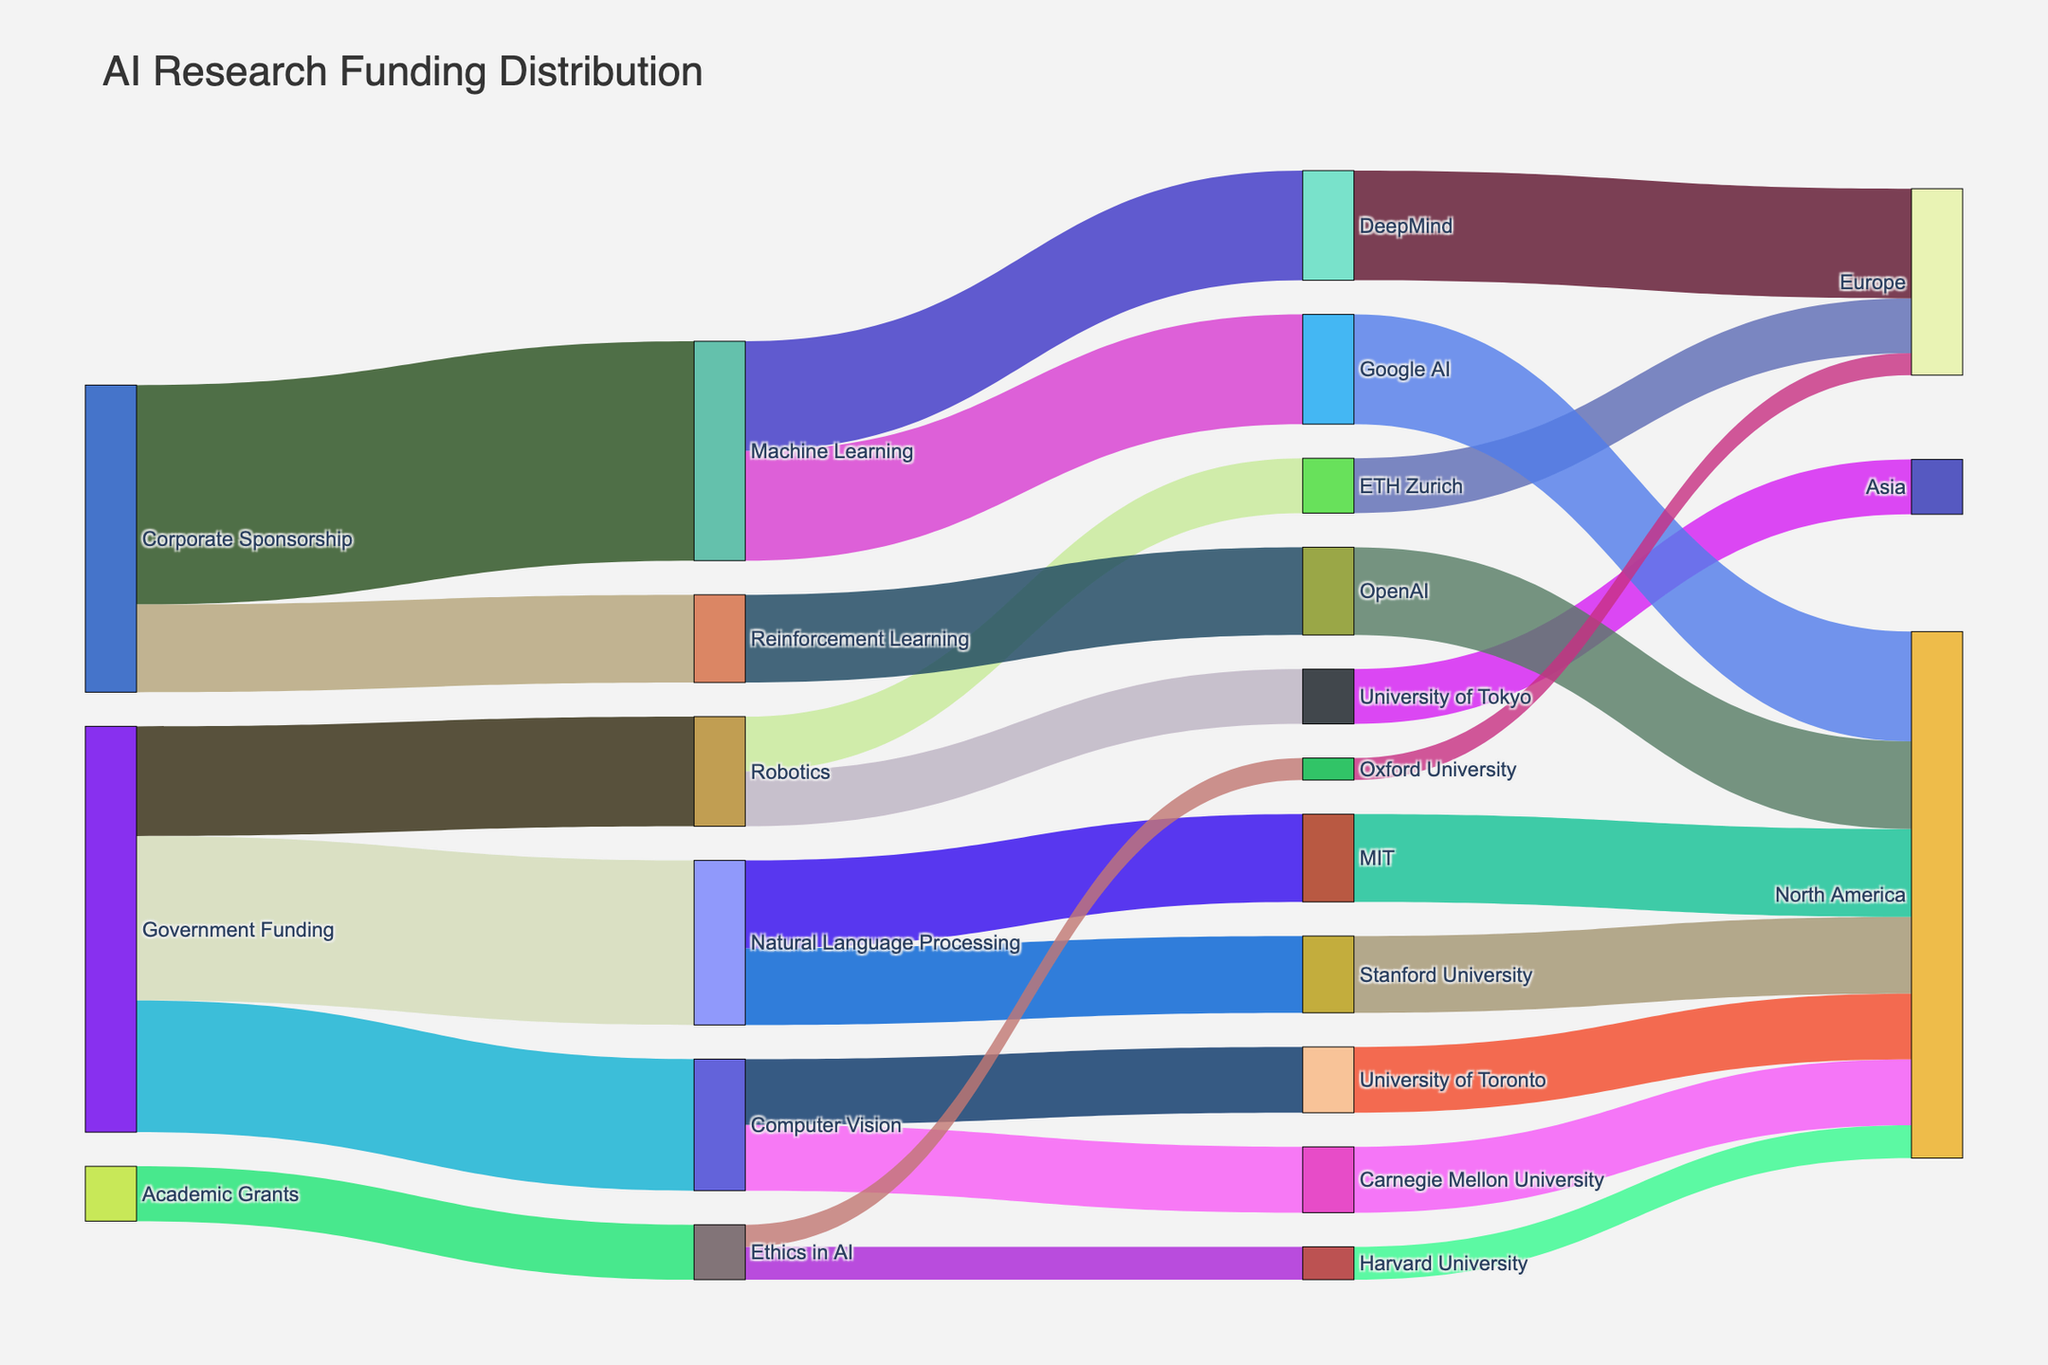What is the title of the Sankey Diagram? The title can be found at the top of the Sankey diagram, which summarizes the content being visualized.
Answer: AI Research Funding Distribution Which institution receives the maximum funding for Natural Language Processing? To find the institution that receives the most funding for Natural Language Processing, trace the largest flow leading from "Natural Language Processing" to an institution.
Answer: MIT What is the total government funding across all AI subfields? Add up the values from the "Government Funding" source that go into each AI subfield: 150 (Natural Language Processing) + 120 (Computer Vision) + 100 (Robotics).
Answer: 370 Compare the funding received by North American institutions versus European institutions. Which region receives more funding? Sum the funding for North American institutions (Stanford University, MIT, Carnegie Mellon University, University of Toronto, Google AI, OpenAI, Harvard University) and compare it with European institutions (ETH Zurich, DeepMind, Oxford University). North American institutions: 70 + 80 + 60 + 60 + 100 + 80 + 30 = 480; European institutions: 50 + 100 + 20 = 170.
Answer: North America What is the total funding received by ETH Zurich? The value can be found by tracing the flow from "Robotics" to "ETH Zurich."
Answer: 50 Identify the subfield that receives the least corporate sponsorship. Among the subfields funded by corporate sponsorship, compare the values: Machine Learning (200), Reinforcement Learning (80).
Answer: Reinforcement Learning Which geographical region gets the most overall funding? Sum the funding amounts directed to each region: North America (70 + 80 + 60 + 60 + 100 + 80 + 30) = 480; Europe (50 + 100 + 20) = 170; Asia (50).
Answer: North America How does funding for Ethics in AI compare between Harvard University and Oxford University? Compare the funding values from the "Ethics in AI" subfield to the respective universities: Harvard (30) vs. Oxford (20).
Answer: Harvard University receives more funding What is the combined funding amount for AI research at Stanford University and MIT? Add the individual funding amounts for these institutions from the "Natural Language Processing" subfield: 70 (Stanford University) + 80 (MIT).
Answer: 150 Who has provided more funding, Government Funding or Corporate Sponsorship? Sum the values for Government Funding (150 + 120 + 100 = 370) and Corporate Sponsorship (200 + 80 = 280) and compare them.
Answer: Government Funding 